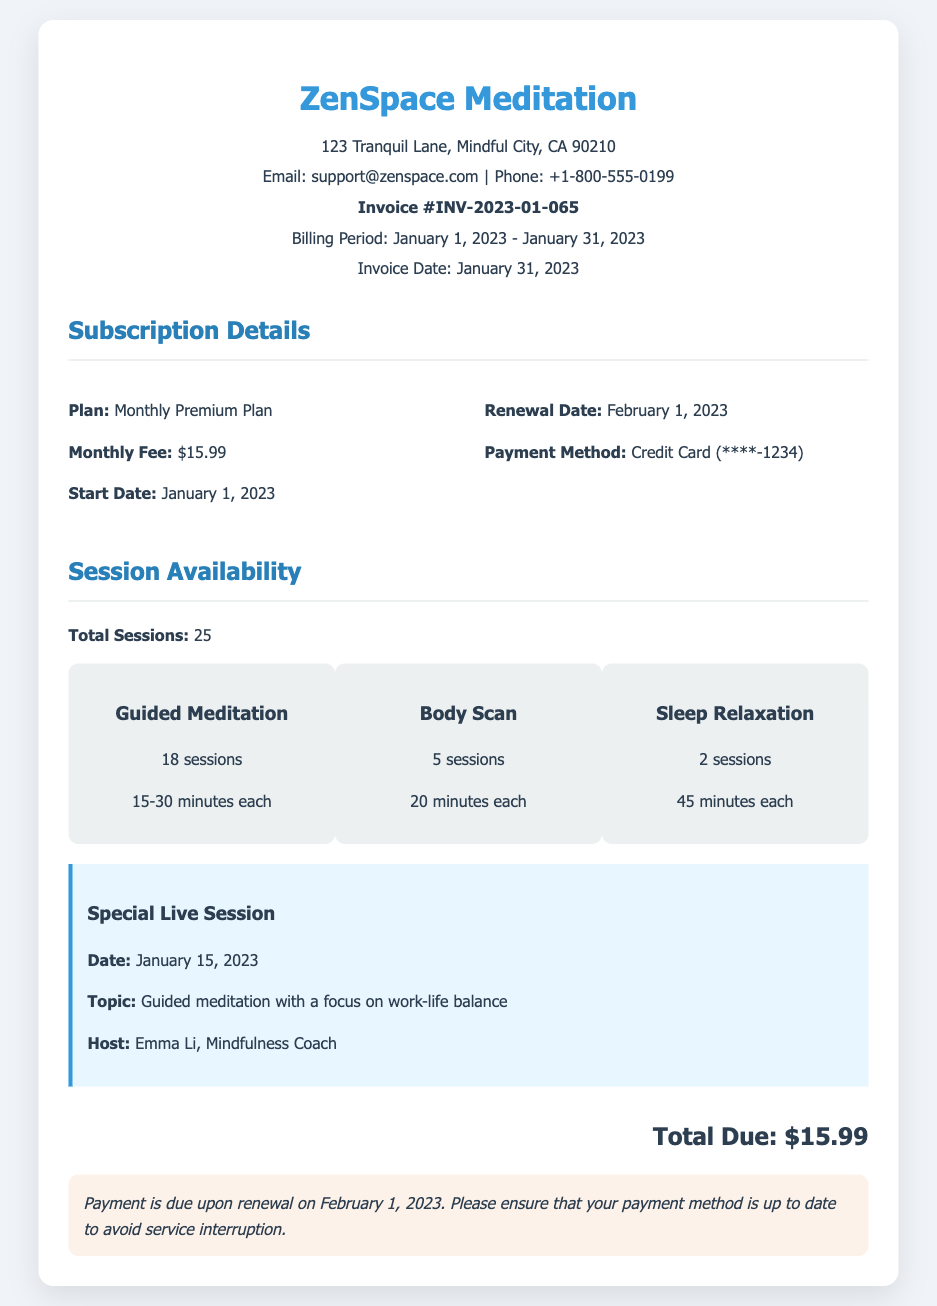What is the billing period? The billing period is specified in the document as the time frame for which the subscription applies, which is from January 1, 2023 to January 31, 2023.
Answer: January 1, 2023 - January 31, 2023 What is the total number of sessions available? The document states the total sessions available to the user during the billing period, which is listed in the session availability section.
Answer: 25 How many Guided Meditation sessions are included? The document specifies the number of guided meditation sessions provided, as mentioned in the session types section.
Answer: 18 sessions What is the total amount due? The document highlights the total amount that needs to be paid for the subscription in the total due section.
Answer: $15.99 What is the date of the special live session? The date for the special live session is detailed in the special event section of the document.
Answer: January 15, 2023 What is the payment method used? The document lists the payment method in the subscription details section, which indicates how the user will be charged.
Answer: Credit Card (****-1234) What is the plan type for the subscription? The plan type is clearly stated in the subscription details as it identifies the level of service provided to the user.
Answer: Monthly Premium Plan Who is the host of the special session? The name of the host for the special live session is provided in the special event section of the document.
Answer: Emma Li, Mindfulness Coach 